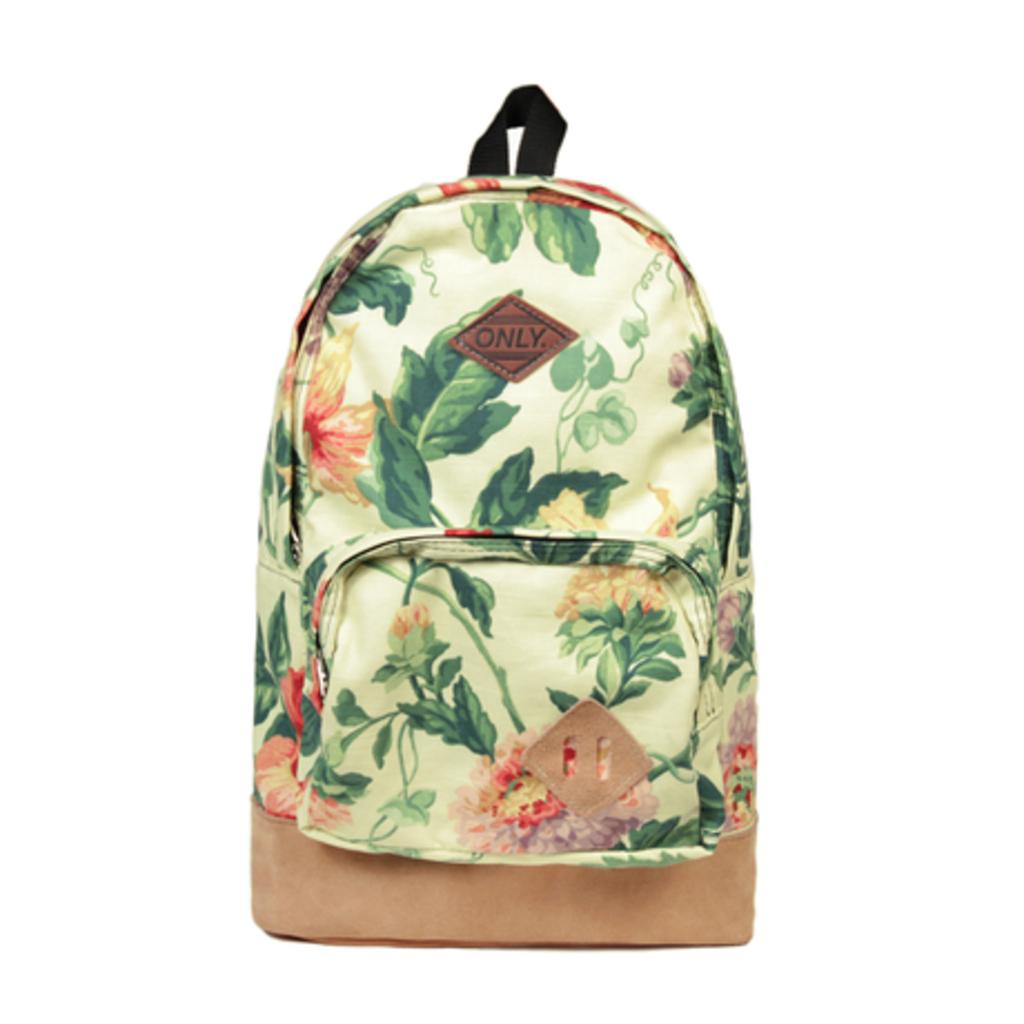What does the bag say on it's leather patch?
Make the answer very short. Only. 